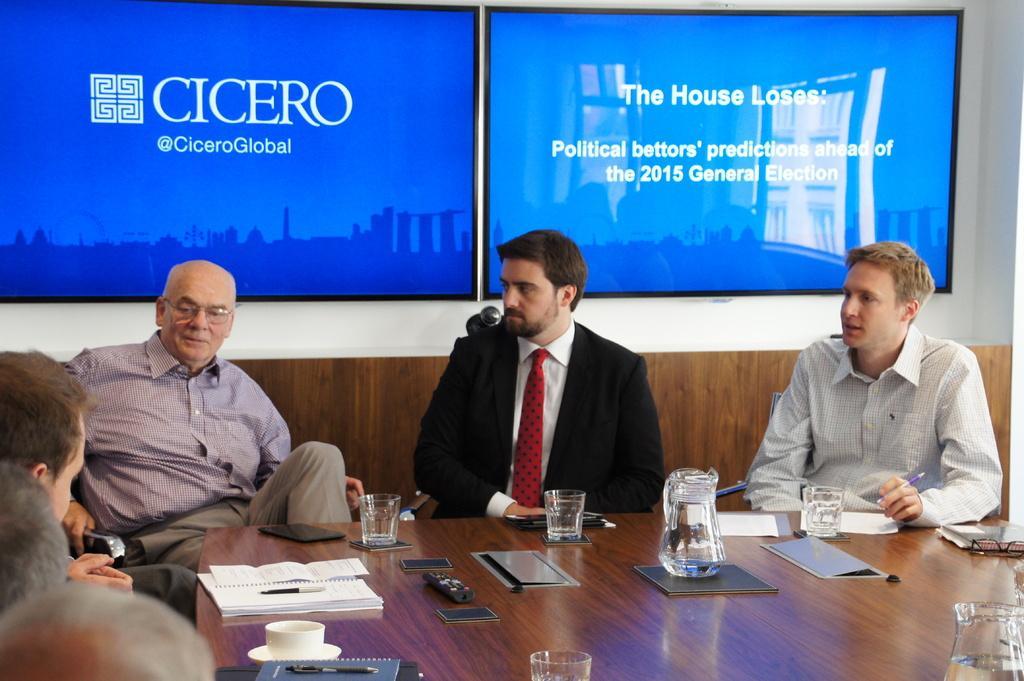Describe this image in one or two sentences. In this image there are a group of people who are sitting, and at the bottom there is a table. On the table there are some books, pens, glasses, cup, saucer and some other objects. In the background there are two televisions on the wall. 